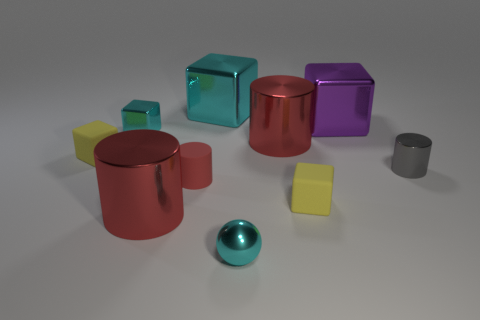Subtract all red cylinders. How many were subtracted if there are1red cylinders left? 2 Subtract all cyan spheres. How many red cylinders are left? 3 Subtract 2 cubes. How many cubes are left? 3 Subtract all cyan blocks. How many blocks are left? 3 Subtract all tiny red cylinders. How many cylinders are left? 3 Subtract all cyan cylinders. Subtract all cyan spheres. How many cylinders are left? 4 Subtract all cylinders. How many objects are left? 6 Subtract all yellow rubber objects. Subtract all cyan objects. How many objects are left? 5 Add 4 large cyan objects. How many large cyan objects are left? 5 Add 6 cyan metal objects. How many cyan metal objects exist? 9 